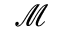<formula> <loc_0><loc_0><loc_500><loc_500>\mathcal { M }</formula> 